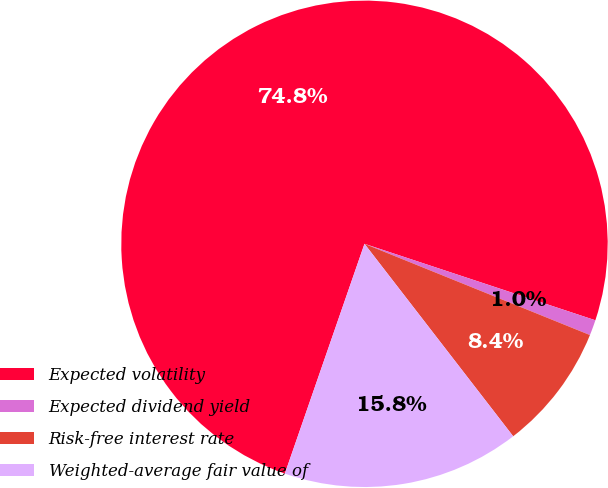Convert chart to OTSL. <chart><loc_0><loc_0><loc_500><loc_500><pie_chart><fcel>Expected volatility<fcel>Expected dividend yield<fcel>Risk-free interest rate<fcel>Weighted-average fair value of<nl><fcel>74.78%<fcel>1.03%<fcel>8.41%<fcel>15.78%<nl></chart> 